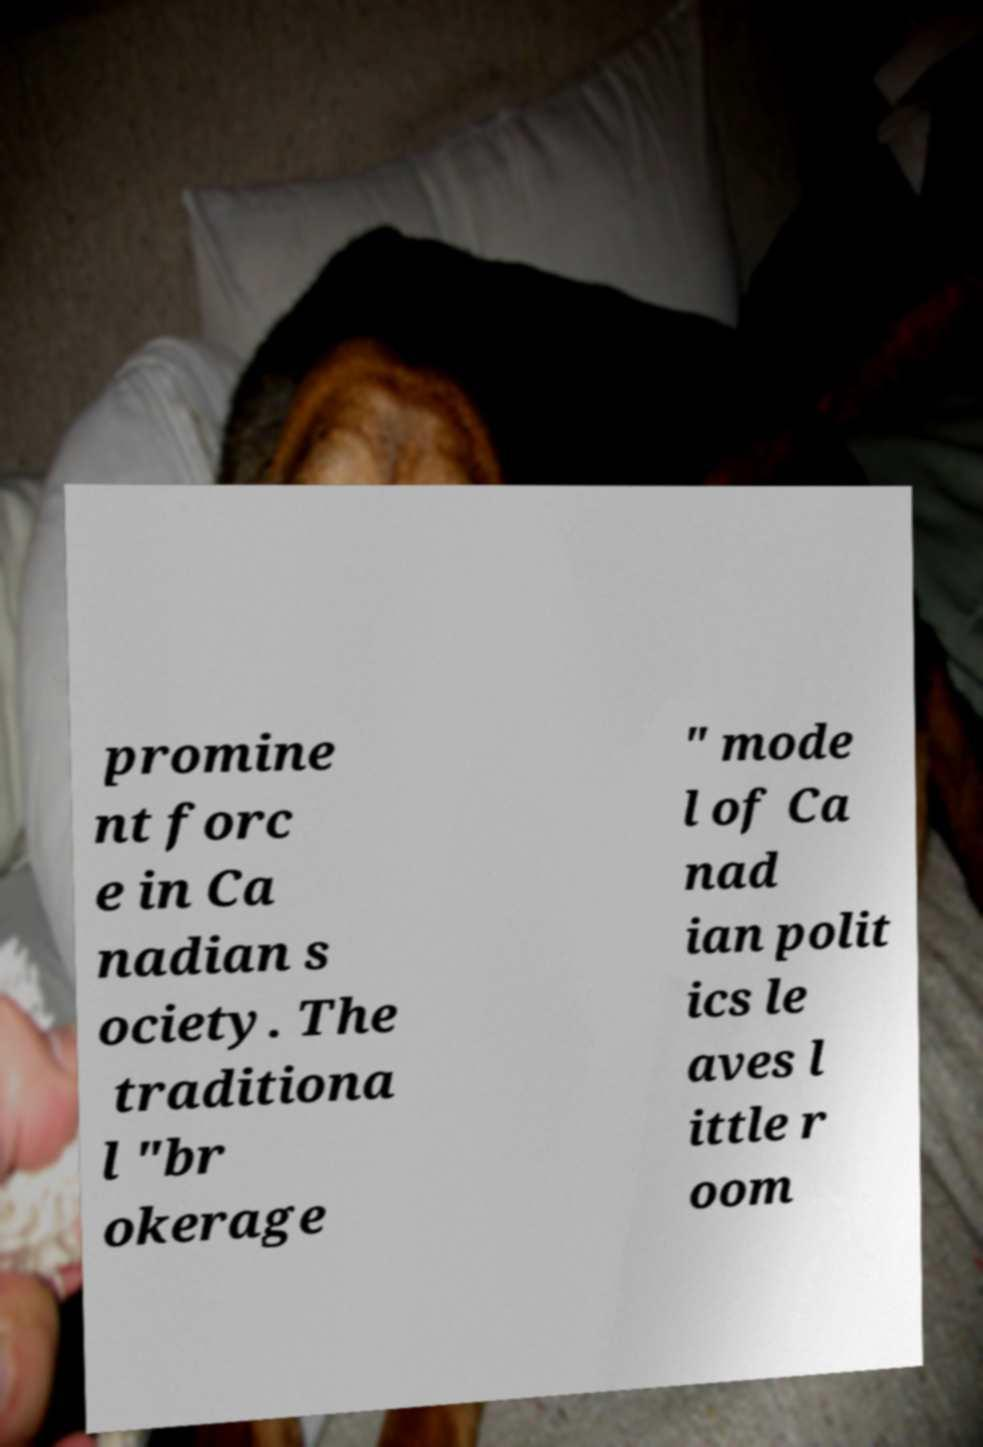Can you read and provide the text displayed in the image?This photo seems to have some interesting text. Can you extract and type it out for me? promine nt forc e in Ca nadian s ociety. The traditiona l "br okerage " mode l of Ca nad ian polit ics le aves l ittle r oom 